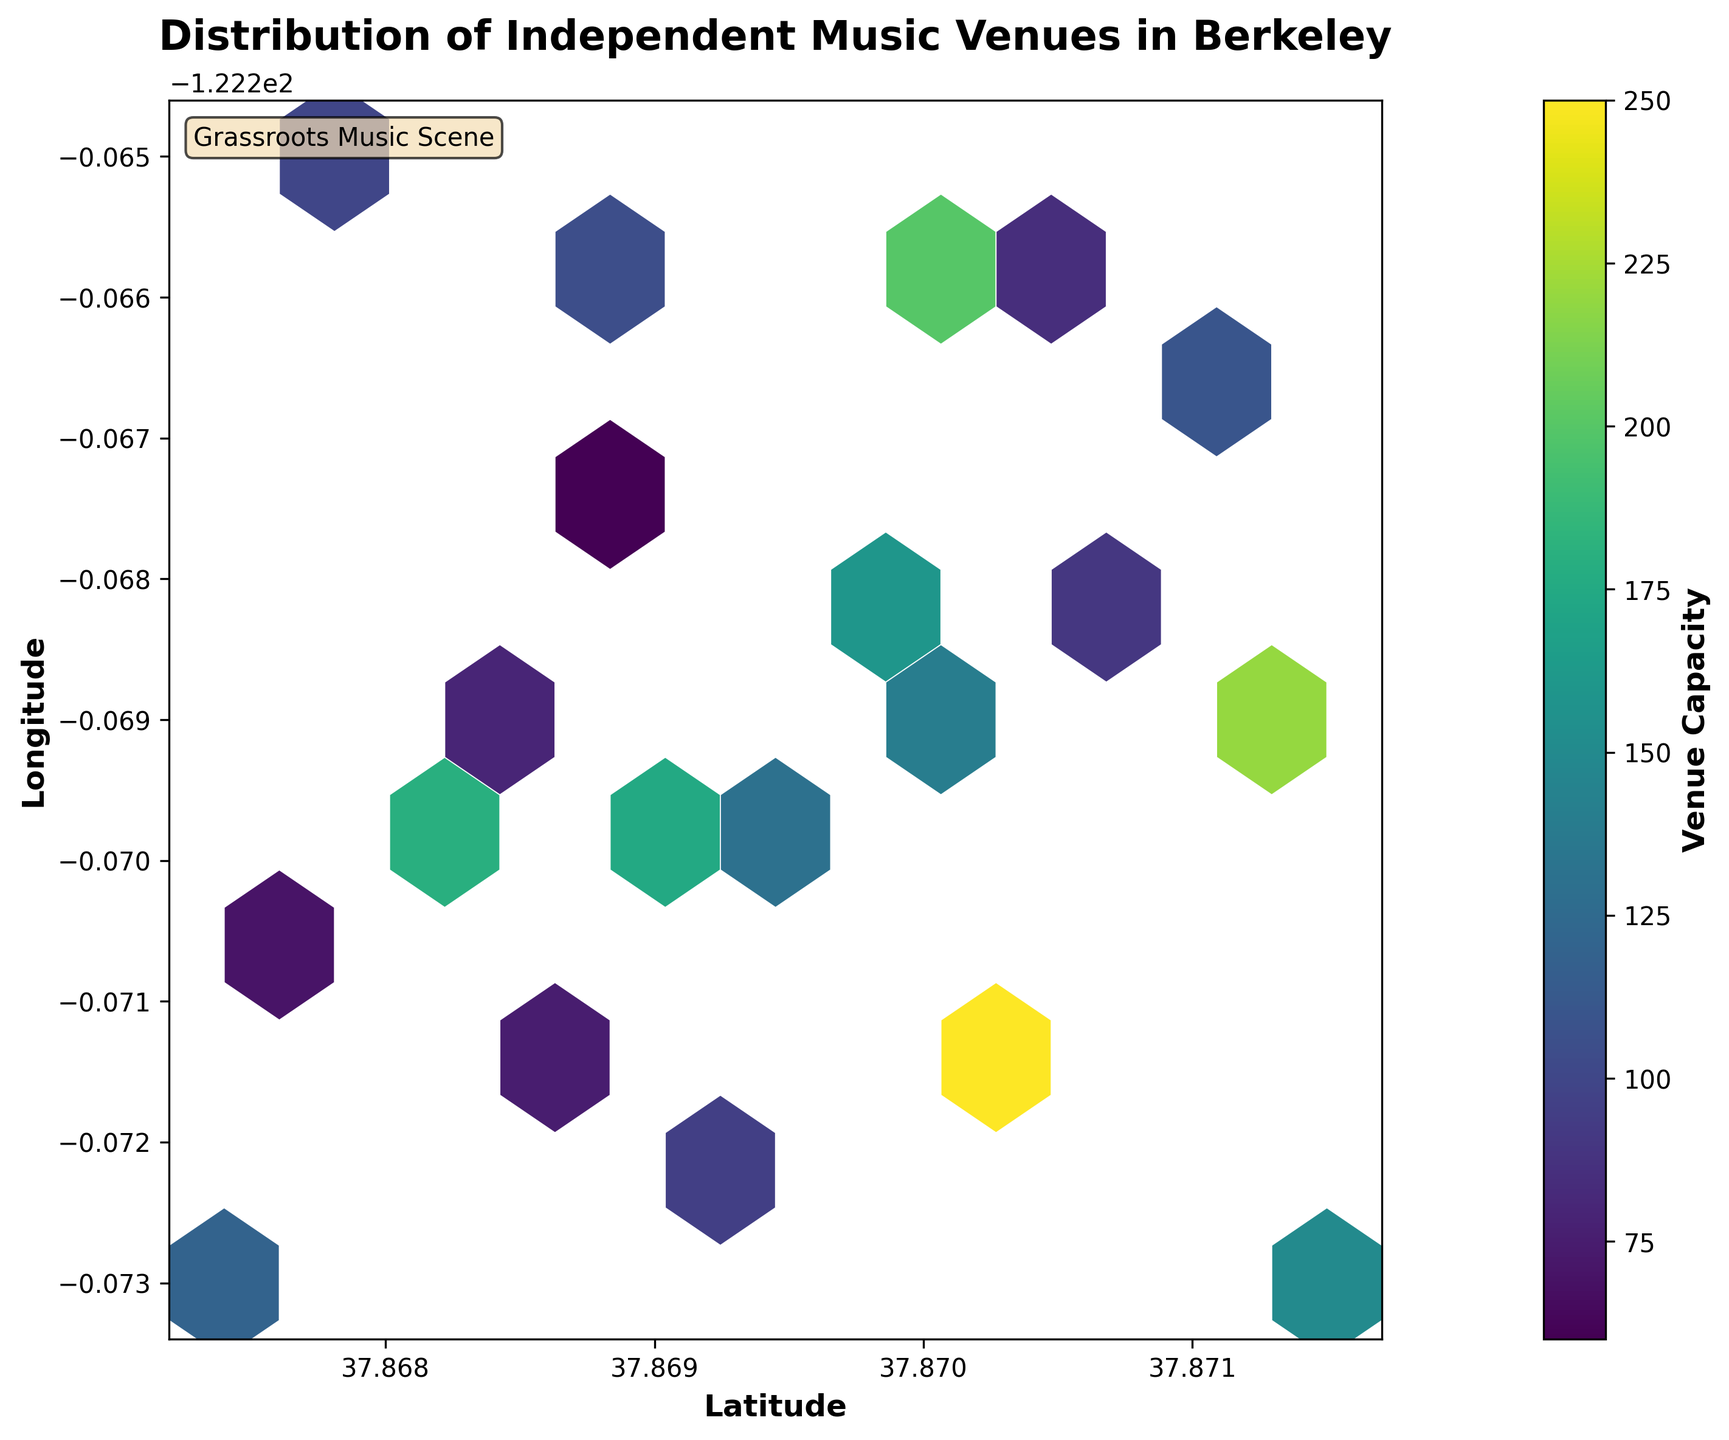What is the title of the plot? The title is presented at the top of the plot. It reads 'Distribution of Independent Music Venues in Berkeley'.
Answer: 'Distribution of Independent Music Venues in Berkeley' What do the colors on the hexbin plot represent? The color bar on the right side of the plot indicates that the colors represent the 'Venue Capacity'.
Answer: 'Venue Capacity' How many hexagons are displayed in the plot? By visually counting, you can count the hexagons in the plot.
Answer: 17 Which axis is labeled 'Latitude'? The bottom horizontal axis is labeled 'Latitude'.
Answer: The x-axis Is there a hexbin with the highest venue capacity, and what color is it? The hexbin with the highest venue capacity will be the darkest in the color scale according to the color bar.
Answer: Dark purple What is the capacity range covered in the plot? The color bar ranges from the lightest color representing low values to the darkest color representing high values. The numerical labels on the color bar can be seen as the range of capacities.
Answer: 60 to 250 How does venue capacity vary as you move from South to North in the plot? Viewing the plot from bottom to top, observe the trend in the colors of the hexagons which indicate capacity. A mix of different colors is seen throughout, indicating no clear trend in capacity variation South to North.
Answer: No clear trend Where are the highest density of music venues located in Berkeley according to the plot? Identify the region with the most hexagons clustered together.
Answer: The center of the plot What impact might the distribution of venue capacities have on local grassroots music initiatives? Assess the distribution and consider varied capacities might allow for diverse types of events, possibly benefitting grassroots initiatives.
Answer: Diverse capacities could support a variety of grassroots events Which hexbin area has the lowest venue capacity? Identify the lightest-colored hexagons in the plot using the color bar for reference. These represent the smallest capacities.
Answer: The light yellow area 